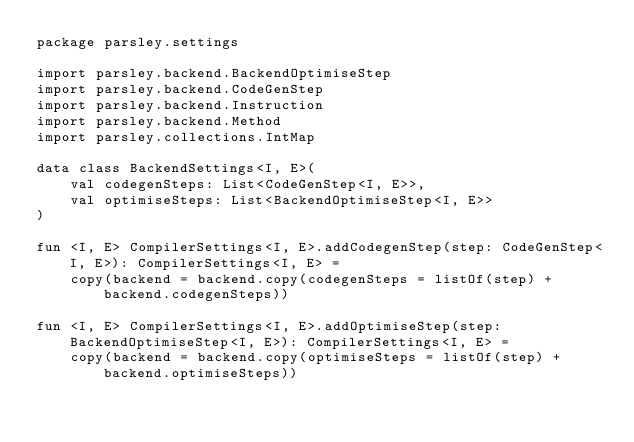<code> <loc_0><loc_0><loc_500><loc_500><_Kotlin_>package parsley.settings

import parsley.backend.BackendOptimiseStep
import parsley.backend.CodeGenStep
import parsley.backend.Instruction
import parsley.backend.Method
import parsley.collections.IntMap

data class BackendSettings<I, E>(
    val codegenSteps: List<CodeGenStep<I, E>>,
    val optimiseSteps: List<BackendOptimiseStep<I, E>>
)

fun <I, E> CompilerSettings<I, E>.addCodegenStep(step: CodeGenStep<I, E>): CompilerSettings<I, E> =
    copy(backend = backend.copy(codegenSteps = listOf(step) + backend.codegenSteps))

fun <I, E> CompilerSettings<I, E>.addOptimiseStep(step: BackendOptimiseStep<I, E>): CompilerSettings<I, E> =
    copy(backend = backend.copy(optimiseSteps = listOf(step) + backend.optimiseSteps))

</code> 